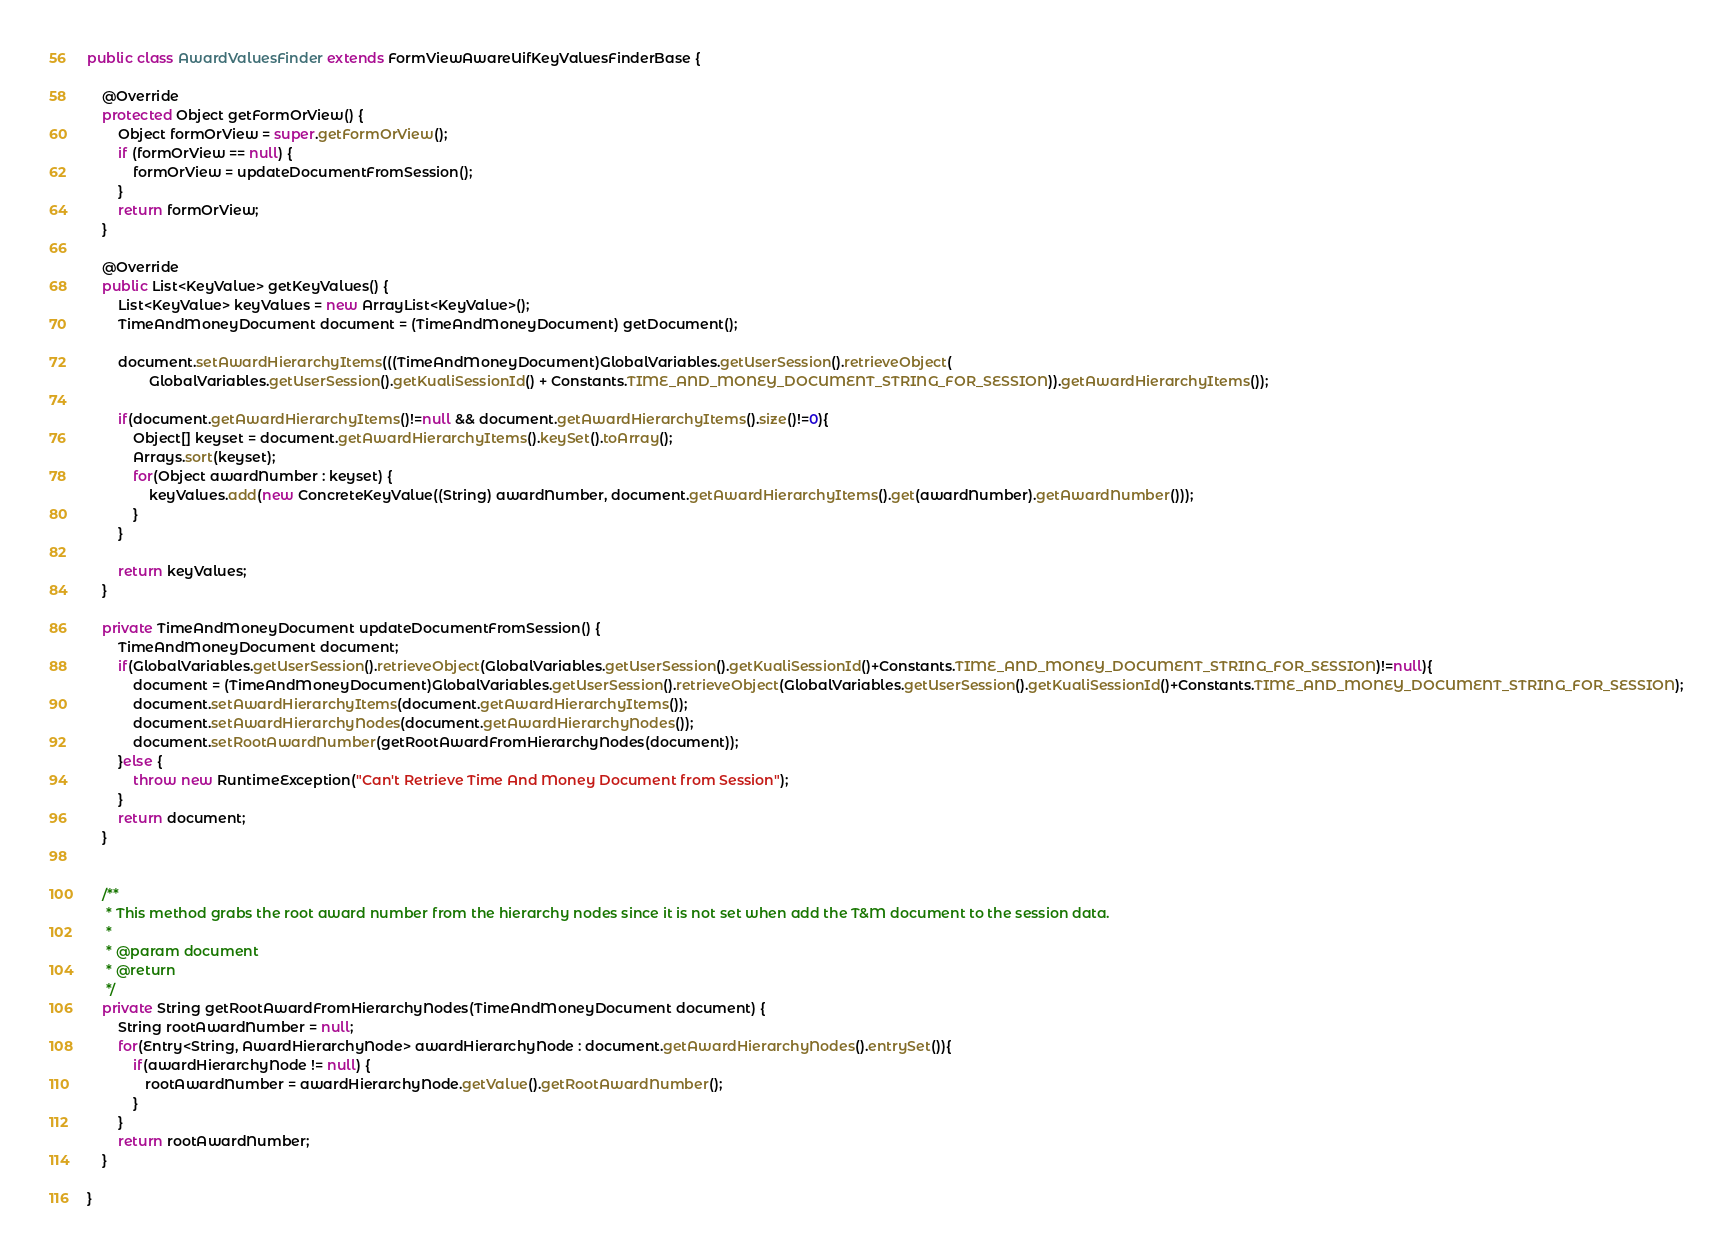Convert code to text. <code><loc_0><loc_0><loc_500><loc_500><_Java_>
public class AwardValuesFinder extends FormViewAwareUifKeyValuesFinderBase {

    @Override
    protected Object getFormOrView() {
        Object formOrView = super.getFormOrView();
        if (formOrView == null) {
            formOrView = updateDocumentFromSession();
        }
        return formOrView;
    }

    @Override
    public List<KeyValue> getKeyValues() {
        List<KeyValue> keyValues = new ArrayList<KeyValue>();
        TimeAndMoneyDocument document = (TimeAndMoneyDocument) getDocument();

        document.setAwardHierarchyItems(((TimeAndMoneyDocument)GlobalVariables.getUserSession().retrieveObject(
                GlobalVariables.getUserSession().getKualiSessionId() + Constants.TIME_AND_MONEY_DOCUMENT_STRING_FOR_SESSION)).getAwardHierarchyItems());    
        
        if(document.getAwardHierarchyItems()!=null && document.getAwardHierarchyItems().size()!=0){
            Object[] keyset = document.getAwardHierarchyItems().keySet().toArray();
            Arrays.sort(keyset);
            for(Object awardNumber : keyset) {
                keyValues.add(new ConcreteKeyValue((String) awardNumber, document.getAwardHierarchyItems().get(awardNumber).getAwardNumber()));
            }
        }
        
        return keyValues;
    }

    private TimeAndMoneyDocument updateDocumentFromSession() {
        TimeAndMoneyDocument document;
        if(GlobalVariables.getUserSession().retrieveObject(GlobalVariables.getUserSession().getKualiSessionId()+Constants.TIME_AND_MONEY_DOCUMENT_STRING_FOR_SESSION)!=null){
            document = (TimeAndMoneyDocument)GlobalVariables.getUserSession().retrieveObject(GlobalVariables.getUserSession().getKualiSessionId()+Constants.TIME_AND_MONEY_DOCUMENT_STRING_FOR_SESSION);
            document.setAwardHierarchyItems(document.getAwardHierarchyItems());
            document.setAwardHierarchyNodes(document.getAwardHierarchyNodes());
            document.setRootAwardNumber(getRootAwardFromHierarchyNodes(document));
        }else {
            throw new RuntimeException("Can't Retrieve Time And Money Document from Session");
        }
        return document;
    }
    
    
    /**
     * This method grabs the root award number from the hierarchy nodes since it is not set when add the T&M document to the session data.
     * 
     * @param document
     * @return
     */
    private String getRootAwardFromHierarchyNodes(TimeAndMoneyDocument document) {
        String rootAwardNumber = null;
        for(Entry<String, AwardHierarchyNode> awardHierarchyNode : document.getAwardHierarchyNodes().entrySet()){
            if(awardHierarchyNode != null) {
               rootAwardNumber = awardHierarchyNode.getValue().getRootAwardNumber();
            }
        }
        return rootAwardNumber;
    }

}
</code> 